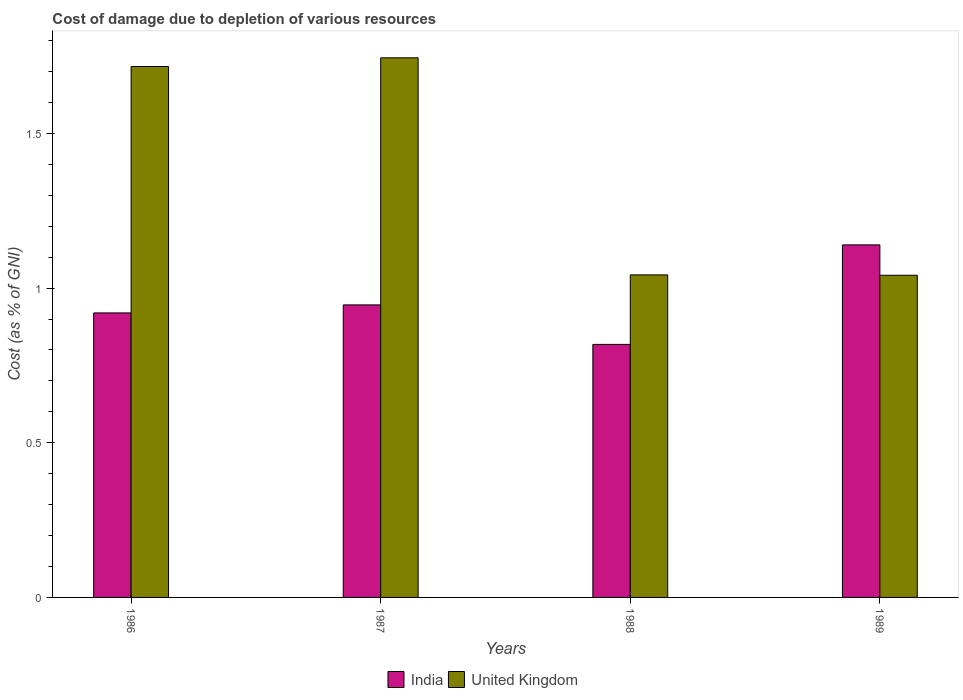How many different coloured bars are there?
Your response must be concise. 2. How many groups of bars are there?
Make the answer very short. 4. Are the number of bars on each tick of the X-axis equal?
Make the answer very short. Yes. How many bars are there on the 3rd tick from the right?
Offer a terse response. 2. What is the cost of damage caused due to the depletion of various resources in United Kingdom in 1988?
Provide a succinct answer. 1.04. Across all years, what is the maximum cost of damage caused due to the depletion of various resources in United Kingdom?
Keep it short and to the point. 1.74. Across all years, what is the minimum cost of damage caused due to the depletion of various resources in United Kingdom?
Give a very brief answer. 1.04. What is the total cost of damage caused due to the depletion of various resources in India in the graph?
Offer a terse response. 3.82. What is the difference between the cost of damage caused due to the depletion of various resources in United Kingdom in 1986 and that in 1987?
Offer a very short reply. -0.03. What is the difference between the cost of damage caused due to the depletion of various resources in India in 1986 and the cost of damage caused due to the depletion of various resources in United Kingdom in 1989?
Provide a succinct answer. -0.12. What is the average cost of damage caused due to the depletion of various resources in India per year?
Ensure brevity in your answer.  0.96. In the year 1988, what is the difference between the cost of damage caused due to the depletion of various resources in India and cost of damage caused due to the depletion of various resources in United Kingdom?
Keep it short and to the point. -0.22. What is the ratio of the cost of damage caused due to the depletion of various resources in India in 1987 to that in 1989?
Give a very brief answer. 0.83. Is the cost of damage caused due to the depletion of various resources in India in 1986 less than that in 1988?
Ensure brevity in your answer.  No. What is the difference between the highest and the second highest cost of damage caused due to the depletion of various resources in United Kingdom?
Provide a succinct answer. 0.03. What is the difference between the highest and the lowest cost of damage caused due to the depletion of various resources in United Kingdom?
Give a very brief answer. 0.7. In how many years, is the cost of damage caused due to the depletion of various resources in United Kingdom greater than the average cost of damage caused due to the depletion of various resources in United Kingdom taken over all years?
Give a very brief answer. 2. Is the sum of the cost of damage caused due to the depletion of various resources in United Kingdom in 1986 and 1987 greater than the maximum cost of damage caused due to the depletion of various resources in India across all years?
Make the answer very short. Yes. How many years are there in the graph?
Your answer should be compact. 4. Does the graph contain any zero values?
Ensure brevity in your answer.  No. Where does the legend appear in the graph?
Give a very brief answer. Bottom center. How many legend labels are there?
Make the answer very short. 2. How are the legend labels stacked?
Make the answer very short. Horizontal. What is the title of the graph?
Your response must be concise. Cost of damage due to depletion of various resources. What is the label or title of the X-axis?
Provide a succinct answer. Years. What is the label or title of the Y-axis?
Your answer should be compact. Cost (as % of GNI). What is the Cost (as % of GNI) in India in 1986?
Your response must be concise. 0.92. What is the Cost (as % of GNI) of United Kingdom in 1986?
Provide a short and direct response. 1.72. What is the Cost (as % of GNI) in India in 1987?
Provide a short and direct response. 0.95. What is the Cost (as % of GNI) in United Kingdom in 1987?
Provide a succinct answer. 1.74. What is the Cost (as % of GNI) in India in 1988?
Ensure brevity in your answer.  0.82. What is the Cost (as % of GNI) in United Kingdom in 1988?
Your answer should be compact. 1.04. What is the Cost (as % of GNI) in India in 1989?
Keep it short and to the point. 1.14. What is the Cost (as % of GNI) in United Kingdom in 1989?
Make the answer very short. 1.04. Across all years, what is the maximum Cost (as % of GNI) in India?
Your response must be concise. 1.14. Across all years, what is the maximum Cost (as % of GNI) in United Kingdom?
Give a very brief answer. 1.74. Across all years, what is the minimum Cost (as % of GNI) in India?
Your response must be concise. 0.82. Across all years, what is the minimum Cost (as % of GNI) in United Kingdom?
Your response must be concise. 1.04. What is the total Cost (as % of GNI) of India in the graph?
Provide a succinct answer. 3.82. What is the total Cost (as % of GNI) in United Kingdom in the graph?
Ensure brevity in your answer.  5.55. What is the difference between the Cost (as % of GNI) of India in 1986 and that in 1987?
Ensure brevity in your answer.  -0.03. What is the difference between the Cost (as % of GNI) in United Kingdom in 1986 and that in 1987?
Your response must be concise. -0.03. What is the difference between the Cost (as % of GNI) in India in 1986 and that in 1988?
Your answer should be very brief. 0.1. What is the difference between the Cost (as % of GNI) in United Kingdom in 1986 and that in 1988?
Keep it short and to the point. 0.67. What is the difference between the Cost (as % of GNI) in India in 1986 and that in 1989?
Keep it short and to the point. -0.22. What is the difference between the Cost (as % of GNI) of United Kingdom in 1986 and that in 1989?
Provide a short and direct response. 0.67. What is the difference between the Cost (as % of GNI) of India in 1987 and that in 1988?
Your answer should be compact. 0.13. What is the difference between the Cost (as % of GNI) of United Kingdom in 1987 and that in 1988?
Offer a terse response. 0.7. What is the difference between the Cost (as % of GNI) in India in 1987 and that in 1989?
Your response must be concise. -0.19. What is the difference between the Cost (as % of GNI) of United Kingdom in 1987 and that in 1989?
Offer a terse response. 0.7. What is the difference between the Cost (as % of GNI) in India in 1988 and that in 1989?
Make the answer very short. -0.32. What is the difference between the Cost (as % of GNI) of United Kingdom in 1988 and that in 1989?
Offer a very short reply. 0. What is the difference between the Cost (as % of GNI) of India in 1986 and the Cost (as % of GNI) of United Kingdom in 1987?
Ensure brevity in your answer.  -0.82. What is the difference between the Cost (as % of GNI) in India in 1986 and the Cost (as % of GNI) in United Kingdom in 1988?
Offer a terse response. -0.12. What is the difference between the Cost (as % of GNI) in India in 1986 and the Cost (as % of GNI) in United Kingdom in 1989?
Make the answer very short. -0.12. What is the difference between the Cost (as % of GNI) in India in 1987 and the Cost (as % of GNI) in United Kingdom in 1988?
Provide a short and direct response. -0.1. What is the difference between the Cost (as % of GNI) in India in 1987 and the Cost (as % of GNI) in United Kingdom in 1989?
Offer a very short reply. -0.1. What is the difference between the Cost (as % of GNI) in India in 1988 and the Cost (as % of GNI) in United Kingdom in 1989?
Ensure brevity in your answer.  -0.22. What is the average Cost (as % of GNI) in India per year?
Ensure brevity in your answer.  0.96. What is the average Cost (as % of GNI) in United Kingdom per year?
Ensure brevity in your answer.  1.39. In the year 1986, what is the difference between the Cost (as % of GNI) in India and Cost (as % of GNI) in United Kingdom?
Provide a short and direct response. -0.8. In the year 1987, what is the difference between the Cost (as % of GNI) in India and Cost (as % of GNI) in United Kingdom?
Your answer should be very brief. -0.8. In the year 1988, what is the difference between the Cost (as % of GNI) in India and Cost (as % of GNI) in United Kingdom?
Keep it short and to the point. -0.22. In the year 1989, what is the difference between the Cost (as % of GNI) in India and Cost (as % of GNI) in United Kingdom?
Keep it short and to the point. 0.1. What is the ratio of the Cost (as % of GNI) in India in 1986 to that in 1987?
Your response must be concise. 0.97. What is the ratio of the Cost (as % of GNI) in United Kingdom in 1986 to that in 1987?
Offer a very short reply. 0.98. What is the ratio of the Cost (as % of GNI) in India in 1986 to that in 1988?
Offer a very short reply. 1.12. What is the ratio of the Cost (as % of GNI) in United Kingdom in 1986 to that in 1988?
Offer a terse response. 1.65. What is the ratio of the Cost (as % of GNI) of India in 1986 to that in 1989?
Your response must be concise. 0.81. What is the ratio of the Cost (as % of GNI) in United Kingdom in 1986 to that in 1989?
Offer a terse response. 1.65. What is the ratio of the Cost (as % of GNI) in India in 1987 to that in 1988?
Your response must be concise. 1.16. What is the ratio of the Cost (as % of GNI) of United Kingdom in 1987 to that in 1988?
Offer a terse response. 1.67. What is the ratio of the Cost (as % of GNI) in India in 1987 to that in 1989?
Make the answer very short. 0.83. What is the ratio of the Cost (as % of GNI) in United Kingdom in 1987 to that in 1989?
Offer a terse response. 1.68. What is the ratio of the Cost (as % of GNI) in India in 1988 to that in 1989?
Give a very brief answer. 0.72. What is the difference between the highest and the second highest Cost (as % of GNI) of India?
Offer a very short reply. 0.19. What is the difference between the highest and the second highest Cost (as % of GNI) of United Kingdom?
Your answer should be compact. 0.03. What is the difference between the highest and the lowest Cost (as % of GNI) of India?
Provide a short and direct response. 0.32. What is the difference between the highest and the lowest Cost (as % of GNI) in United Kingdom?
Ensure brevity in your answer.  0.7. 